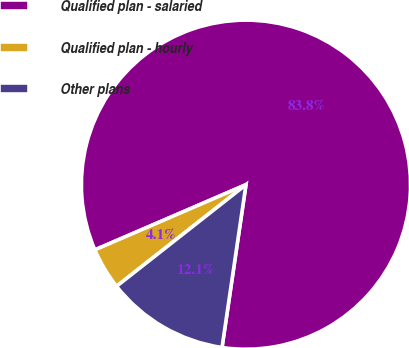Convert chart to OTSL. <chart><loc_0><loc_0><loc_500><loc_500><pie_chart><fcel>Qualified plan - salaried<fcel>Qualified plan - hourly<fcel>Other plans<nl><fcel>83.8%<fcel>4.11%<fcel>12.08%<nl></chart> 